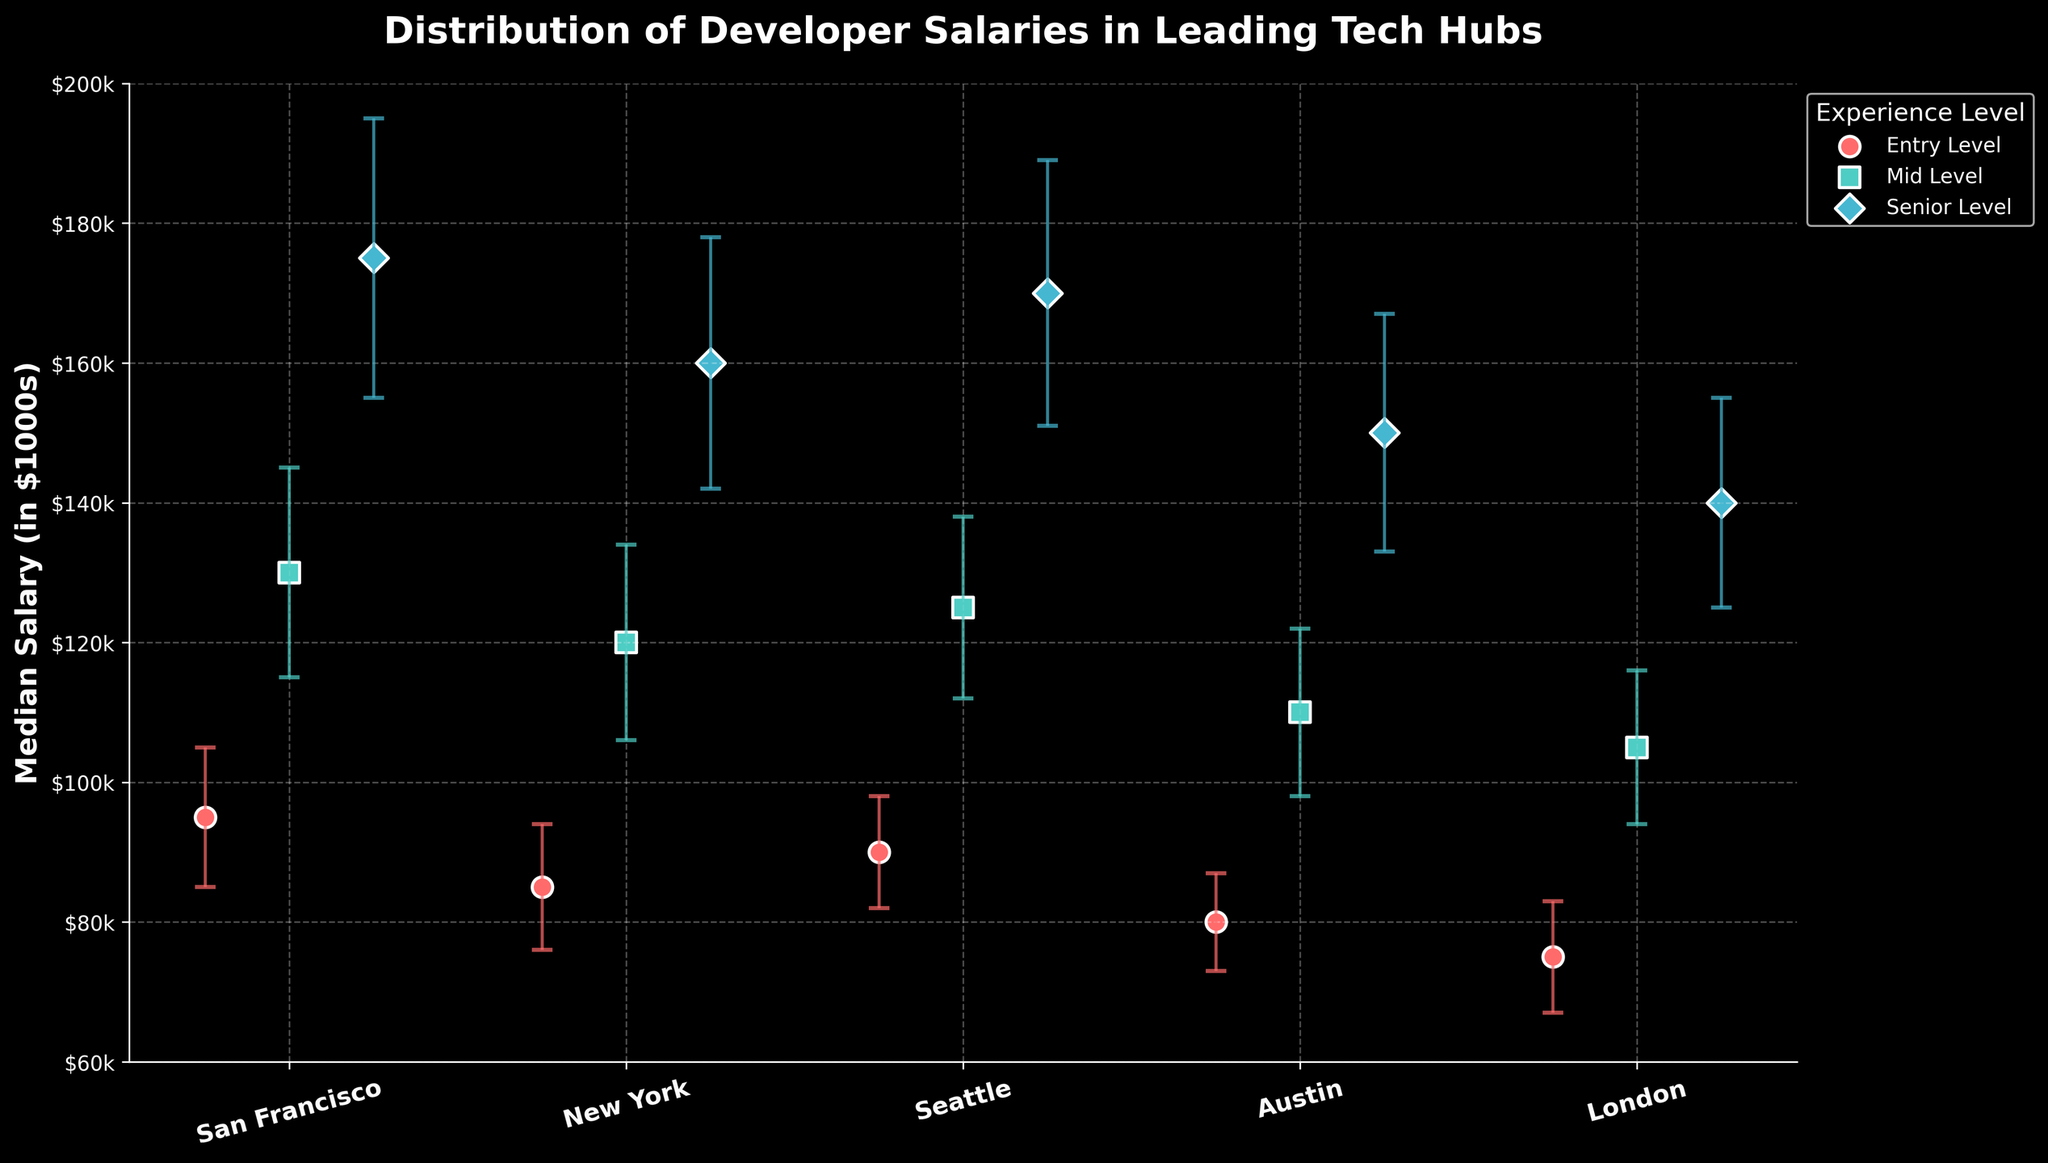What is the title of the plot? The title of the plot is displayed at the top and reads "Distribution of Developer Salaries in Leading Tech Hubs."
Answer: Distribution of Developer Salaries in Leading Tech Hubs What is the y-axis representing? The y-axis label indicates it represents the "Median Salary (in $1000s)."
Answer: Median Salary (in $1000s) Which tech hub has the highest median salary for Senior Level developers? By looking at the Senior Level dots (denoted by "D" markers and blue color) on the plot, the dot for San Francisco is the highest on the y-axis compared to other tech hubs.
Answer: San Francisco What is the specific median salary for Entry Level developers in Austin? By locating the Entry Level markers (denoted by "o" markers and red color) and checking the dot positioned on Austin, the median salary is at the value of 80 on the y-axis.
Answer: 80 How does the median salary for Mid Level developers in New York compare to that in Seattle? By looking at the Mid Level markers (denoted by "s" markers and green color), New York has a value of 120 on the y-axis, whereas Seattle is at 125. Thus, Seattle's median salary is higher.
Answer: Seattle Considering standard deviations, which tech hub has the most variability in Senior Level salaries? By examining the length of the error bars on the Senior Level blue dots, San Francisco has the largest range because its error bars are the longest (±20).
Answer: San Francisco What is the range of median salaries for Mid Level developers across all tech hubs? The lowest dot for Mid Level is London at 105, and the highest is San Francisco at 130. Hence, the range is 130 - 105 = 25.
Answer: 25 How many different experience levels are shown in the plot? By analyzing the legend, there are three different experience levels indicated: Entry Level, Mid Level, and Senior Level.
Answer: 3 Which tech hub has the smallest standard deviation for Entry Level developers, and what is that value? By examining the error bars on the Entry Level red dots, Austin has the smallest error bar for Entry Level developers, at ±7.
Answer: Austin What is the difference between the median salary for Senior Level developers in London and Mid Level developers in San Francisco? From the plot, London Senior Level median salary is 140, and San Francisco Mid Level is 130. The difference is 140 - 130 = 10.
Answer: 10 